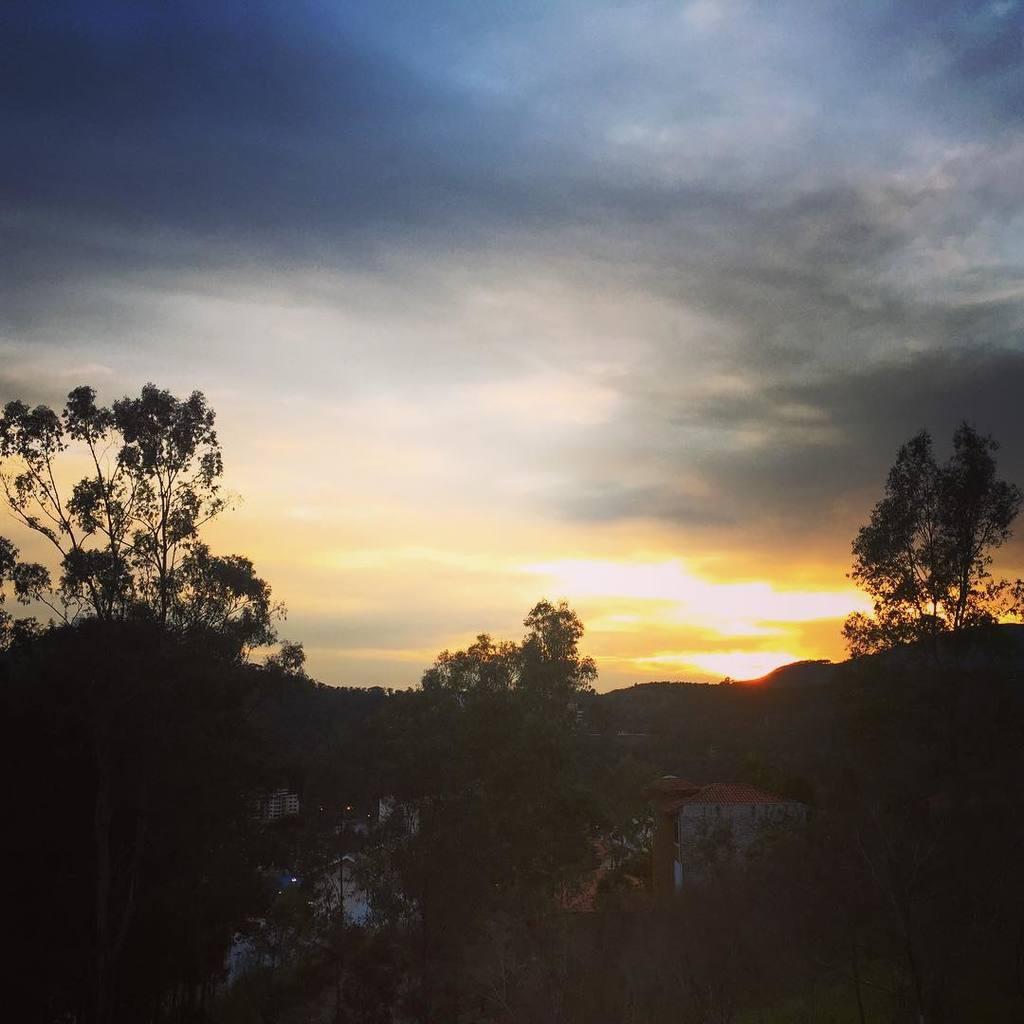How would you summarize this image in a sentence or two? In this image we can see there are buildings, trees and the sky. 